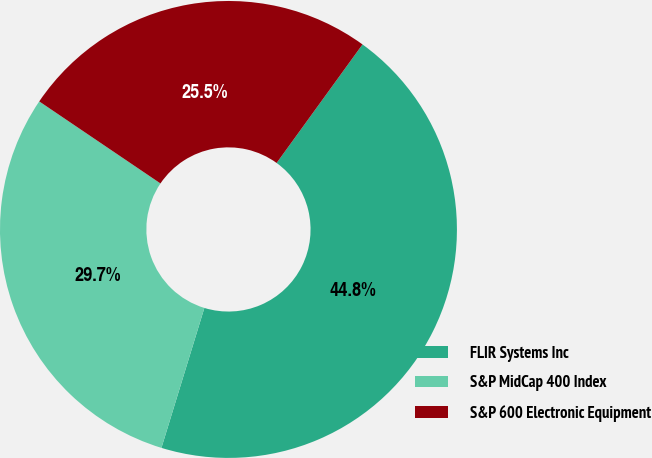<chart> <loc_0><loc_0><loc_500><loc_500><pie_chart><fcel>FLIR Systems Inc<fcel>S&P MidCap 400 Index<fcel>S&P 600 Electronic Equipment<nl><fcel>44.76%<fcel>29.73%<fcel>25.51%<nl></chart> 